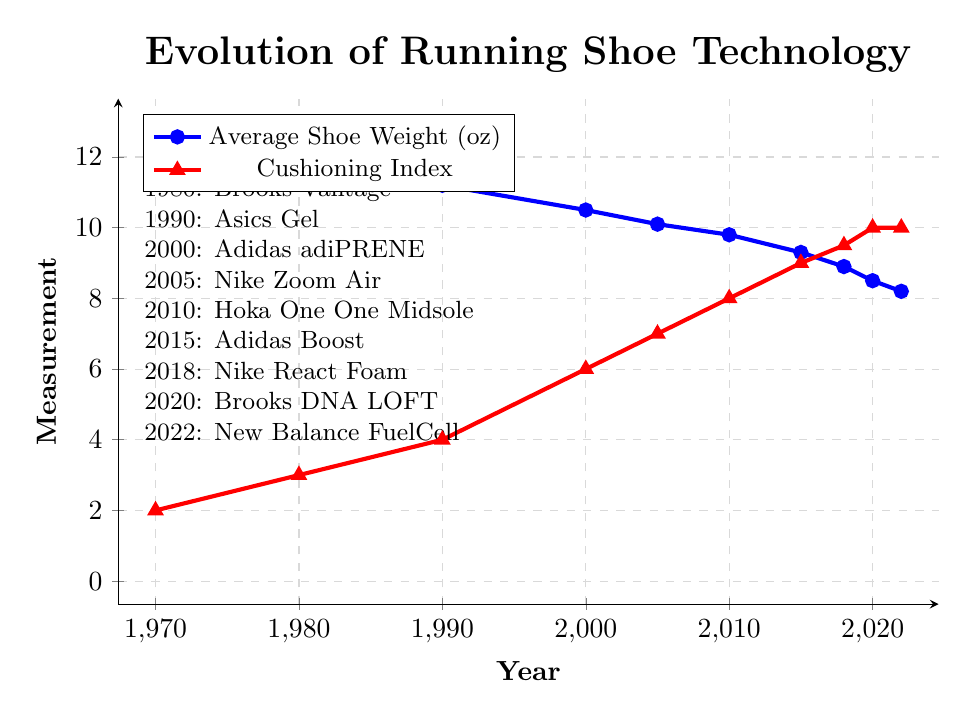What's the average shoe weight in the 2000s? To find the average shoe weight for the 2000s, identify the data points for the years 2000, 2005, and 2010. Sum these values: 10.5 (2000) + 10.1 (2005) + 9.8 (2010) = 30.4. Divide by the number of years: 30.4 / 3 = 10.13.
Answer: 10.13 Which year saw the most significant weight reduction in running shoes? To determine the year with the most significant weight reduction, calculate the yearly differences in shoe weights and identify the largest decrease: 12.5 (1970 to 1980) - 11.8 = 0.7, 11.8 (1980 to 1990) - 11.2 = 0.6, 11.2 (1990 to 2000) - 10.5 = 0.7, 10.5 (2000 to 2005) - 10.1 = 0.4, 10.1 (2005 to 2010) - 9.8 = 0.3, 9.8 (2010 to 2015) - 9.3 = 0.5, 9.3 (2015 to 2018) - 8.9 = 0.4, and 8.5 (2020 to 2022) - 8.2 = 0.3. The largest decrease is from 1970 to 1980, by 0.7 oz.
Answer: 1970 to 1980 Which notable technology introduced in 2020, and what is the corresponding cushioning index? Look for the technologies introduced in the specified years. According to the figure, Brooks DNA LOFT was notable in 2020, with a cushioning index of 10.
Answer: Brooks DNA LOFT, 10 How many years did it take for the cushioning index to reach 10 from its value of 2 in 1970? Identify the years when the cushioning index was 2 and 10. In 1970, it was 2, and it reached 10 in 2020. Subtract the initial year from the final year: 2020 - 1970 = 50.
Answer: 50 years Did any year have both the lowest shoe weight and the highest cushioning index? Identify the lowest shoe weight and highest cushioning index, then compare the years. The lowest shoe weight is 8.2 oz in 2022, and the highest cushioning index is 10 in 2020 and 2022. In 2022, both the lowest weight and highest cushioning index occurred.
Answer: 2022 What is the weight difference between running shoes in 2010 and 2015? Find the shoe weights for the years 2010 and 2015: 9.8 oz (2010), 9.3 oz (2015). Subtract the 2015 weight from the 2010 weight: 9.8 - 9.3 = 0.5 oz.
Answer: 0.5 oz Which color represents the cushioning index in the plot? Refer to the visual attributes of the plot, identifying the color associated with the Cushioning Index. The cushioning index is represented by red.
Answer: Red 